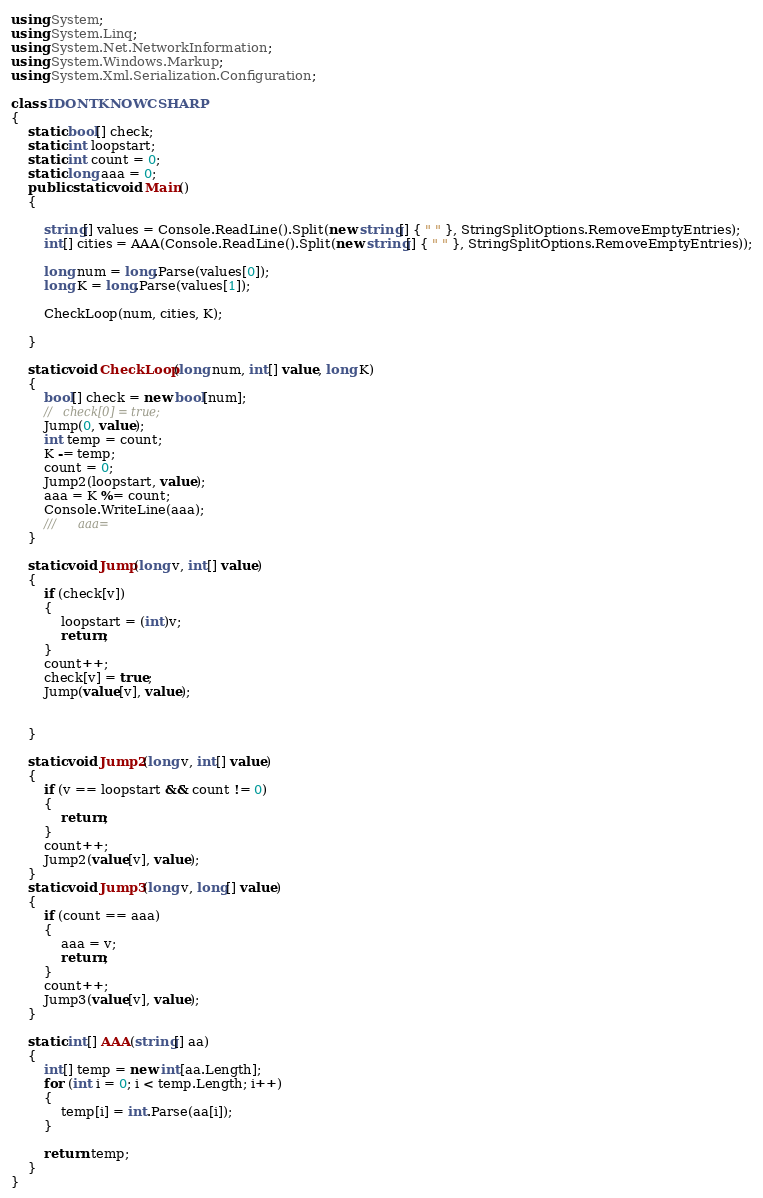<code> <loc_0><loc_0><loc_500><loc_500><_C#_>
using System;
using System.Linq;
using System.Net.NetworkInformation;
using System.Windows.Markup;
using System.Xml.Serialization.Configuration;

class IDONTKNOWCSHARP
{
    static bool[] check;
    static int loopstart;
    static int count = 0;
    static long aaa = 0;
    public static void Main()
    {

        string[] values = Console.ReadLine().Split(new string[] { " " }, StringSplitOptions.RemoveEmptyEntries);
        int[] cities = AAA(Console.ReadLine().Split(new string[] { " " }, StringSplitOptions.RemoveEmptyEntries));

        long num = long.Parse(values[0]);
        long K = long.Parse(values[1]);

        CheckLoop(num, cities, K);

    }

    static void CheckLoop(long num, int[] value, long K)
    {
        bool[] check = new bool[num];
        //   check[0] = true;
        Jump(0, value);
        int temp = count;
        K -= temp;
        count = 0;
        Jump2(loopstart, value);
        aaa = K %= count;
        Console.WriteLine(aaa);
        ///      aaa=
    }

    static void Jump(long v, int[] value)
    {
        if (check[v])
        {
            loopstart = (int)v;
            return;
        }
        count++;
        check[v] = true;
        Jump(value[v], value);


    }

    static void Jump2(long v, int[] value)
    {
        if (v == loopstart && count != 0)
        {
            return;
        }
        count++;
        Jump2(value[v], value);
    }
    static void Jump3(long v, long[] value)
    {
        if (count == aaa)
        {
            aaa = v;
            return;
        }
        count++;
        Jump3(value[v], value);
    }

    static int[] AAA(string[] aa)
    {
        int[] temp = new int[aa.Length];
        for (int i = 0; i < temp.Length; i++)
        {
            temp[i] = int.Parse(aa[i]);
        }

        return temp;
    }
}</code> 